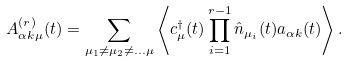<formula> <loc_0><loc_0><loc_500><loc_500>A _ { \alpha k \mu } ^ { ( r ) } ( t ) = \sum _ { \mu _ { 1 } \neq \mu _ { 2 } \neq \dots \mu } \left \langle c _ { \mu } ^ { \dagger } ( t ) \prod _ { i = 1 } ^ { r - 1 } \hat { n } _ { \mu _ { i } } ( t ) a _ { \alpha k } ( t ) \right \rangle .</formula> 